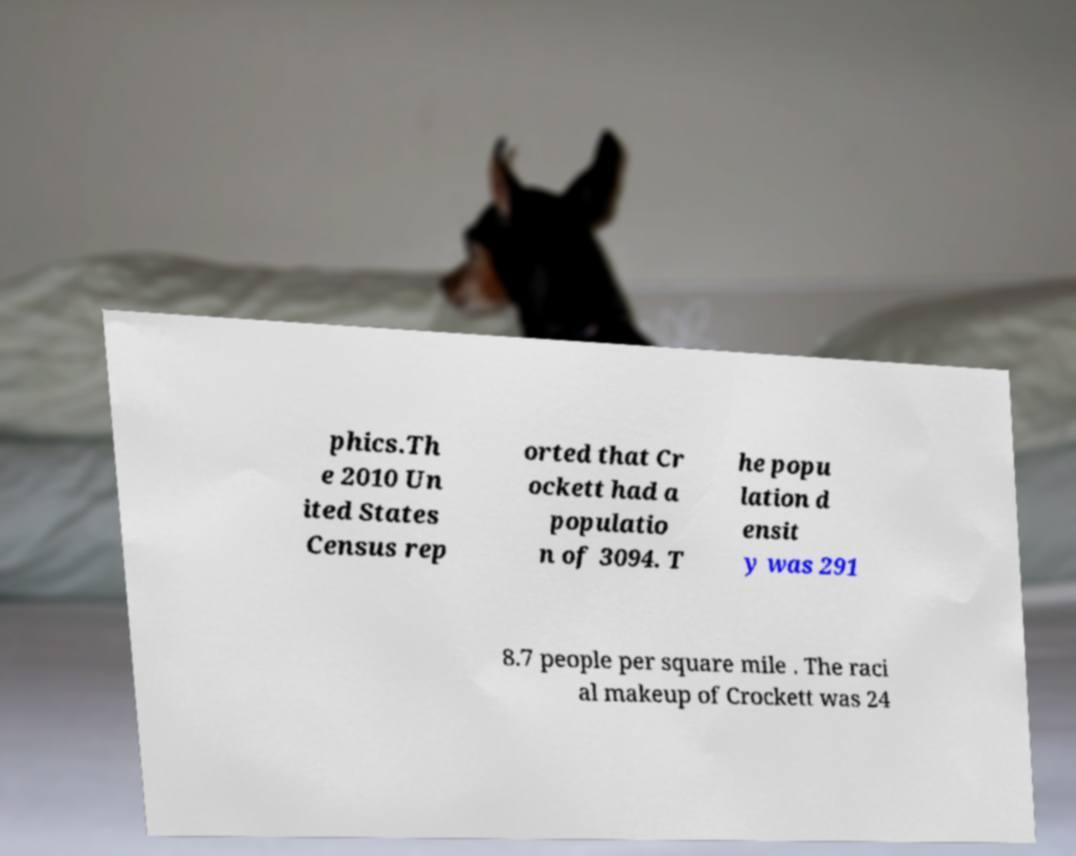There's text embedded in this image that I need extracted. Can you transcribe it verbatim? phics.Th e 2010 Un ited States Census rep orted that Cr ockett had a populatio n of 3094. T he popu lation d ensit y was 291 8.7 people per square mile . The raci al makeup of Crockett was 24 